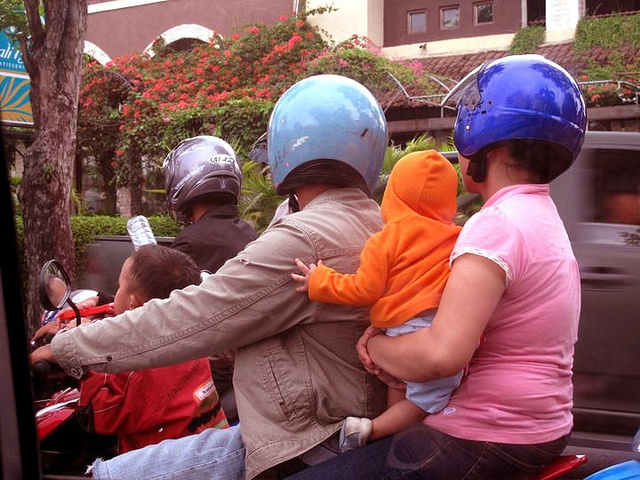Describe the objects in this image and their specific colors. I can see people in olive, gray, maroon, darkgray, and brown tones, people in olive, black, brown, violet, and lightpink tones, people in olive, maroon, brown, and black tones, truck in olive, maroon, black, and gray tones, and people in olive, red, orange, and brown tones in this image. 